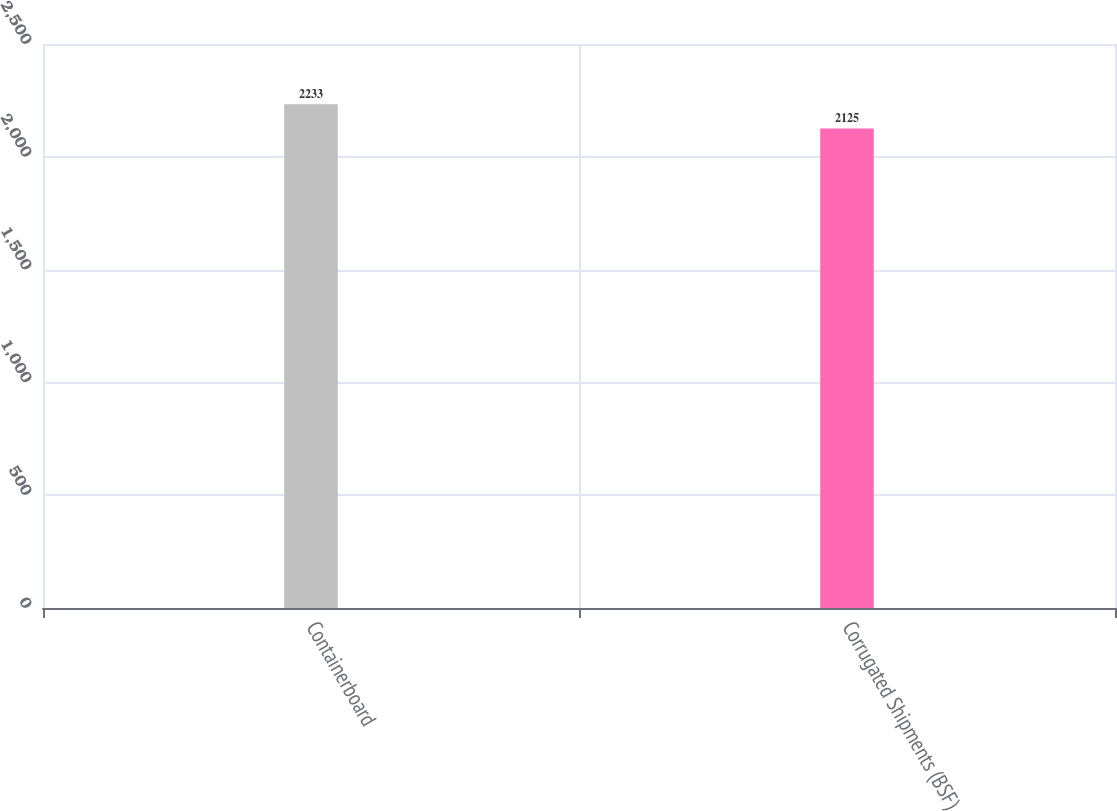<chart> <loc_0><loc_0><loc_500><loc_500><bar_chart><fcel>Containerboard<fcel>Corrugated Shipments (BSF)<nl><fcel>2233<fcel>2125<nl></chart> 